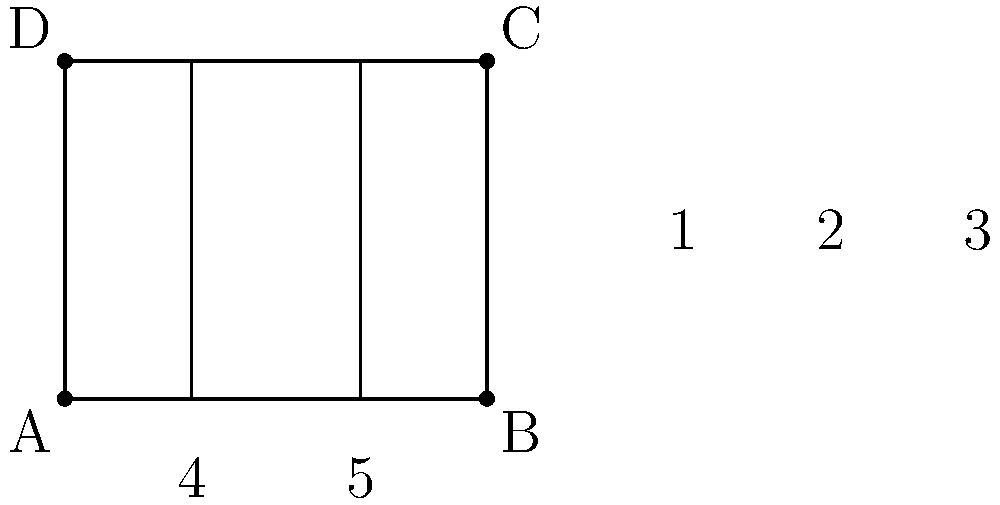In a parallel pipe installation, three vertical pipes are arranged as shown in the diagram. Given that the outer pipes are parallel to each other and perpendicular to the horizontal surfaces, which of the following statements about the angles is true?

a) Angle 1 is congruent to angle 3
b) Angle 2 is congruent to angle 4
c) Angle 4 is congruent to angle 5
d) All of the above Let's analyze this step-by-step:

1) First, we know that the outer pipes are parallel to each other and perpendicular to the horizontal surfaces. This creates a rectangular shape overall.

2) In a rectangle, opposite sides are parallel. This means that the top and bottom horizontal surfaces are parallel to each other.

3) When a line (in this case, our middle pipe) intersects two parallel lines, corresponding angles are congruent. This means:
   - Angle 1 is congruent to angle 3 (corresponding angles)

4) When a line is perpendicular to a plane, it forms right angles (90°) with any line in that plane that passes through the point of intersection. This means:
   - Angle 4 and angle 5 are both right angles (90°)
   - Since they're both 90°, angle 4 is congruent to angle 5

5) In a rectangle, all interior angles are right angles (90°). This means:
   - Angle 2 is a right angle (90°)
   - Since angle 4 is also a right angle, angle 2 is congruent to angle 4

Therefore, all the statements (a, b, and c) are true.
Answer: d) All of the above 